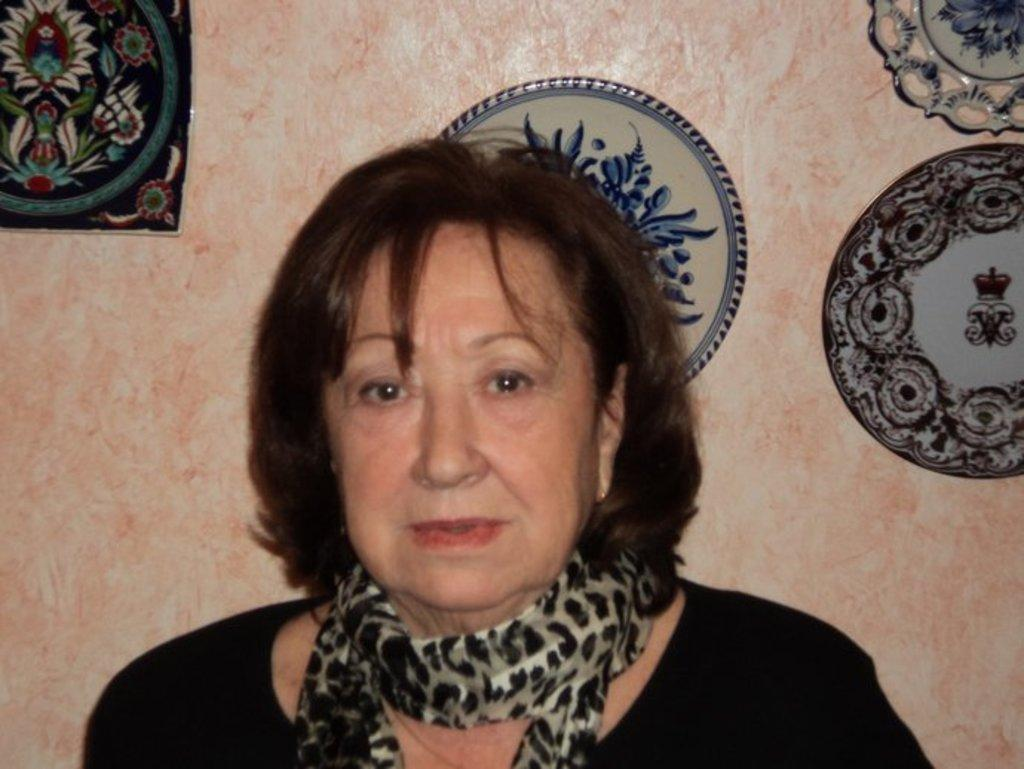Who is present in the image? There is a woman in the image. What can be seen on the wall in the background of the image? There are glazed tin plates on the wall in the background of the image. What type of worm can be seen crawling on the woman's shoulder in the image? There is no worm present in the image; it only features a woman and glazed tin plates on the wall. 